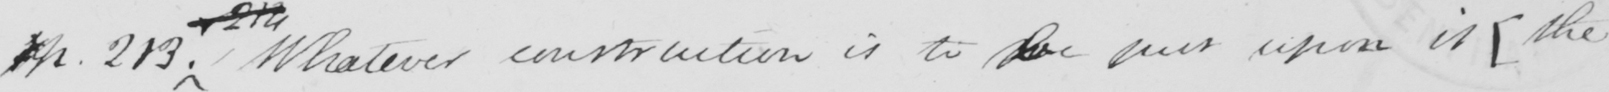Please transcribe the handwritten text in this image. p . 213 . Whatever construction is to be put upon it  [ the 